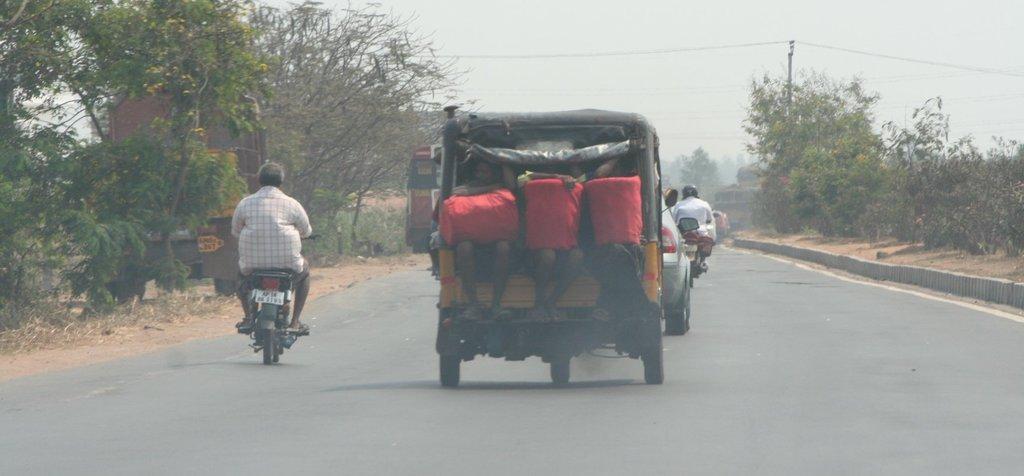Can you describe this image briefly? In the image we can see there are vehicles on the road. There are even people wearing clothes, here we can see trees, grass, electric wires and the sky. 